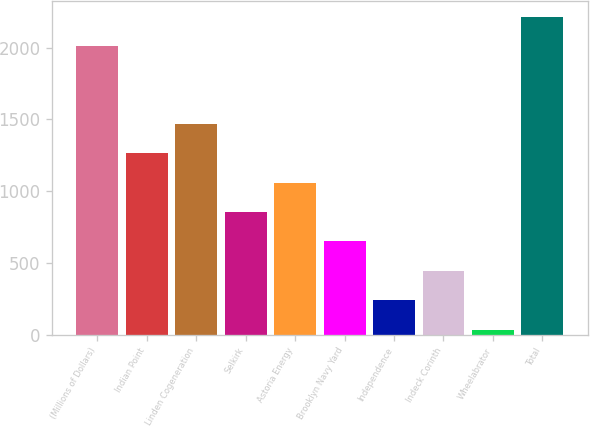Convert chart. <chart><loc_0><loc_0><loc_500><loc_500><bar_chart><fcel>(Millions of Dollars)<fcel>Indian Point<fcel>Linden Cogeneration<fcel>Selkirk<fcel>Astoria Energy<fcel>Brooklyn Navy Yard<fcel>Independence<fcel>Indeck Corinth<fcel>Wheelabrator<fcel>Total<nl><fcel>2008<fcel>1264.4<fcel>1469.3<fcel>854.6<fcel>1059.5<fcel>649.7<fcel>239.9<fcel>444.8<fcel>35<fcel>2212.9<nl></chart> 